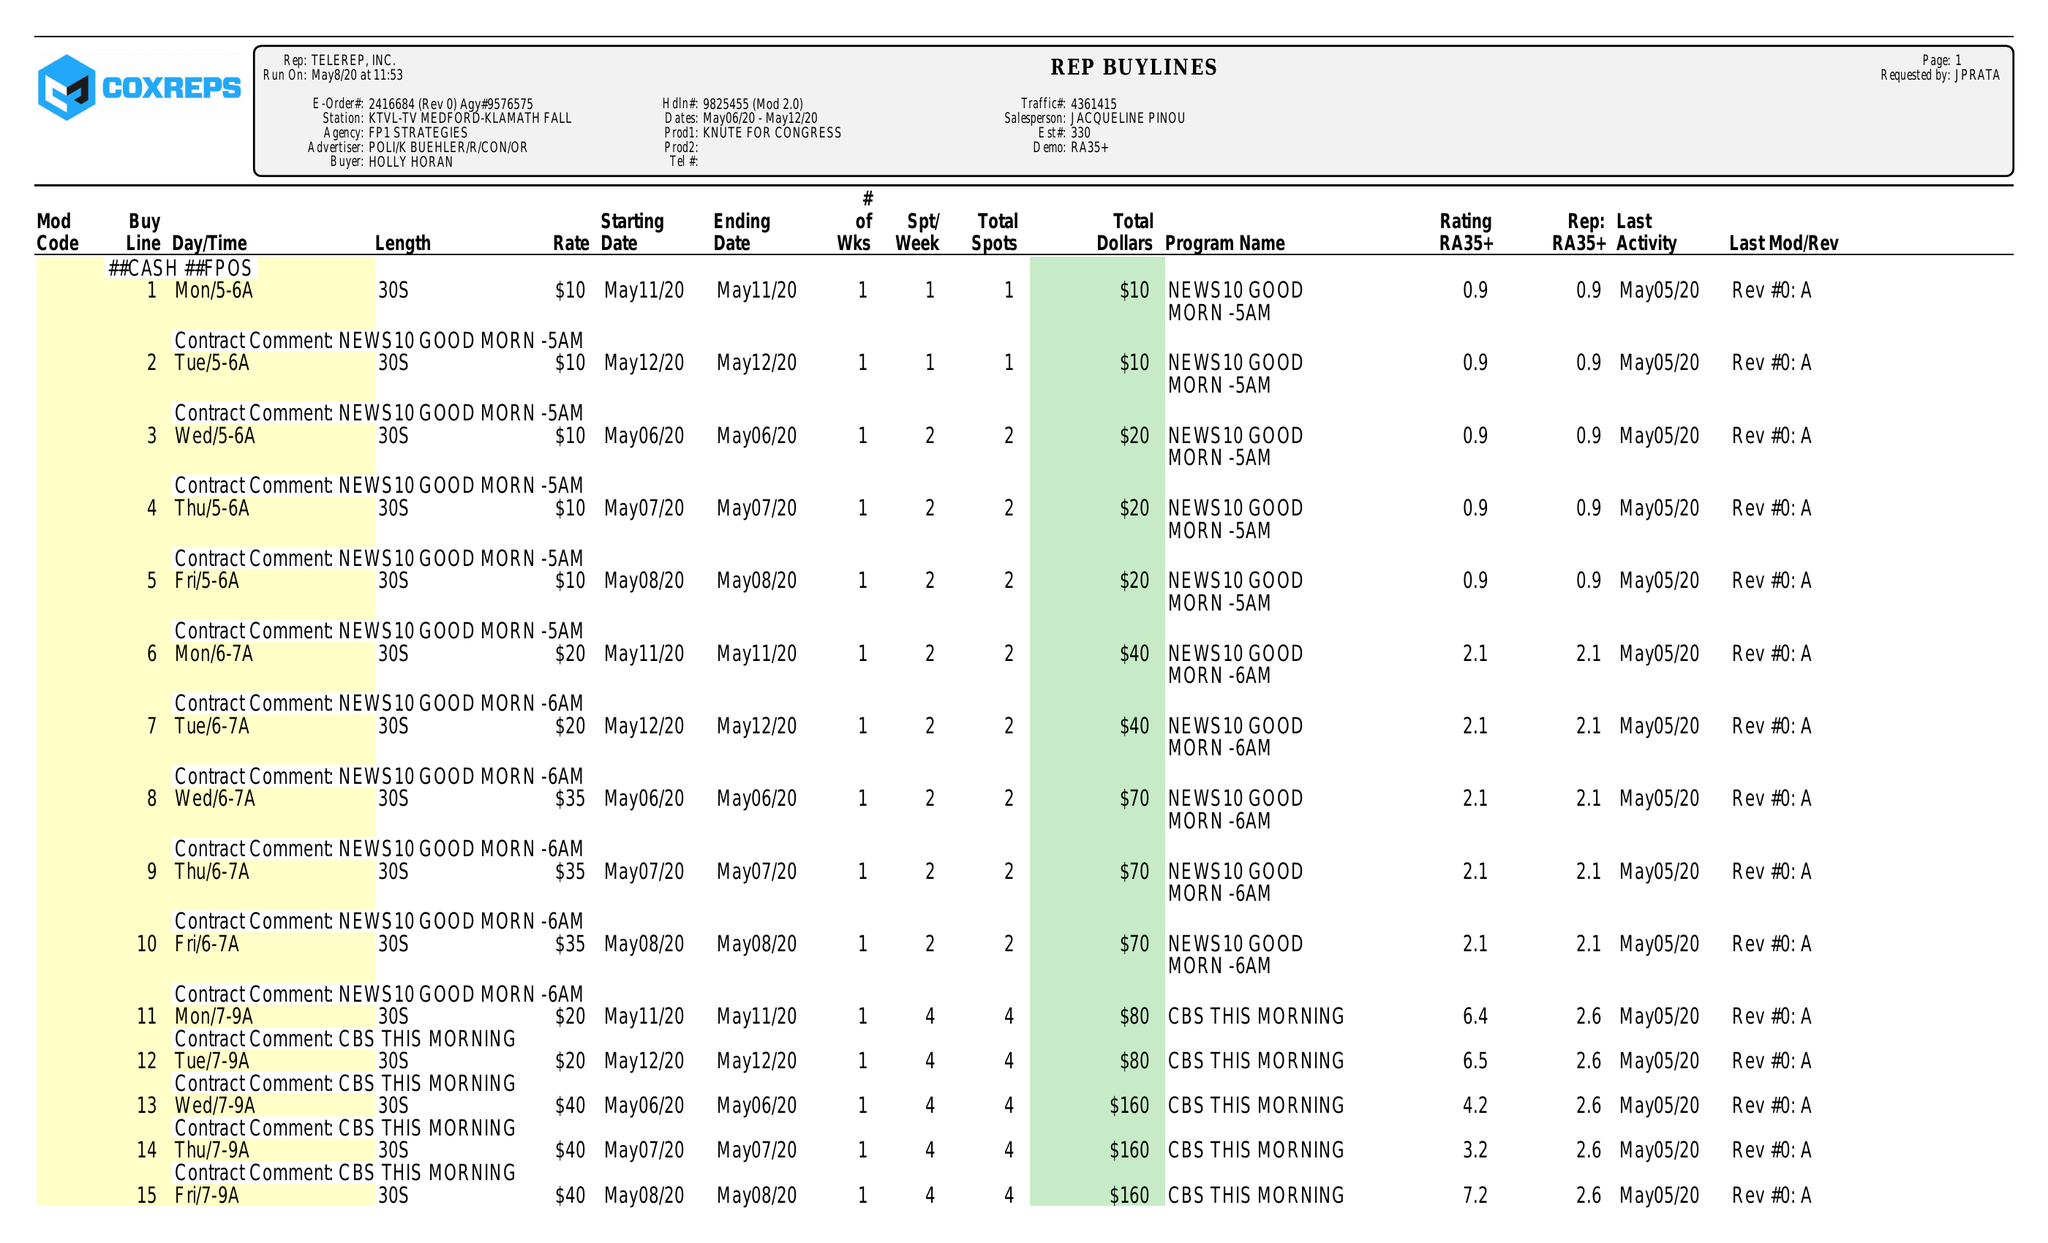What is the value for the gross_amount?
Answer the question using a single word or phrase. 8970.00 